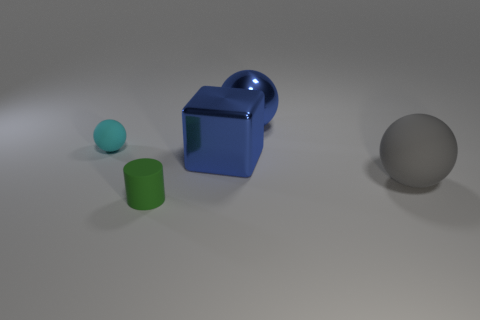The cylinder is what color?
Your answer should be compact. Green. Are there more big blocks that are behind the green matte thing than cyan things in front of the blue block?
Offer a terse response. Yes. What is the color of the tiny matte object that is behind the matte cylinder?
Offer a terse response. Cyan. There is a cyan rubber sphere left of the big gray rubber sphere; is it the same size as the green matte cylinder in front of the metal sphere?
Provide a short and direct response. Yes. How many things are small matte cylinders or cyan matte spheres?
Provide a short and direct response. 2. There is a small object that is to the right of the small matte thing that is on the left side of the small rubber cylinder; what is its material?
Your answer should be very brief. Rubber. What number of other small objects are the same shape as the gray thing?
Ensure brevity in your answer.  1. Is there a large sphere of the same color as the cube?
Your response must be concise. Yes. What number of things are tiny things in front of the gray matte sphere or spheres that are on the right side of the small cyan thing?
Your answer should be compact. 3. There is a large ball in front of the tiny matte ball; are there any tiny matte objects that are behind it?
Provide a succinct answer. Yes. 